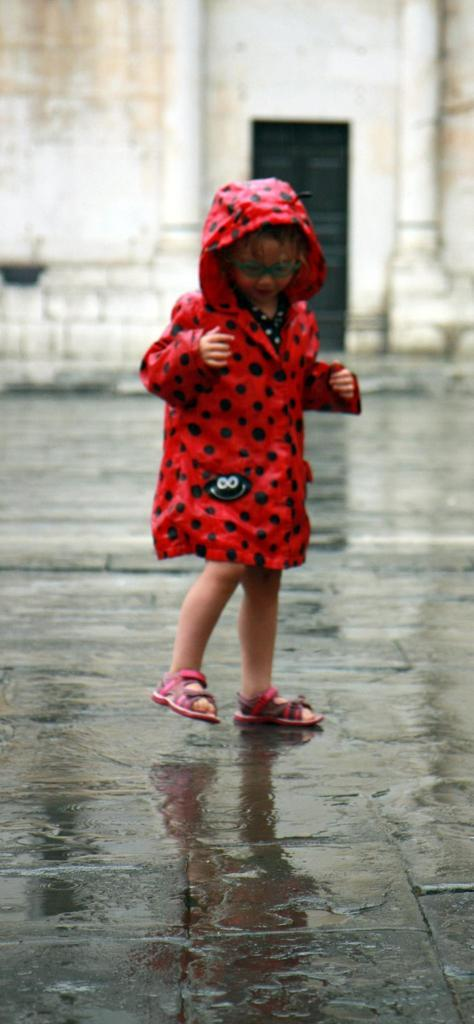What is the main subject of the image? The main subject of the image is a kid standing. What is located at the bottom of the image? There is water at the bottom of the image. What can be seen in the background of the image? There is a wall and a door in the background of the image. What type of hairstyle does the kid have in the image? The provided facts do not mention the kid's hairstyle, so it cannot be determined from the image. How many chickens are visible in the image? There are no chickens present in the image. 